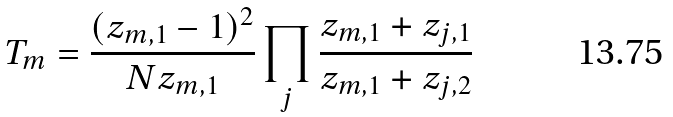Convert formula to latex. <formula><loc_0><loc_0><loc_500><loc_500>T _ { m } = \frac { ( z _ { m , 1 } - 1 ) ^ { 2 } } { N z _ { m , 1 } } \prod _ { j } \frac { z _ { m , 1 } + z _ { j , 1 } } { z _ { m , 1 } + z _ { j , 2 } }</formula> 